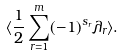<formula> <loc_0><loc_0><loc_500><loc_500>\langle \frac { 1 } { 2 } \sum _ { r = 1 } ^ { m } ( - 1 ) ^ { s _ { r } } \lambda _ { r } \rangle .</formula> 